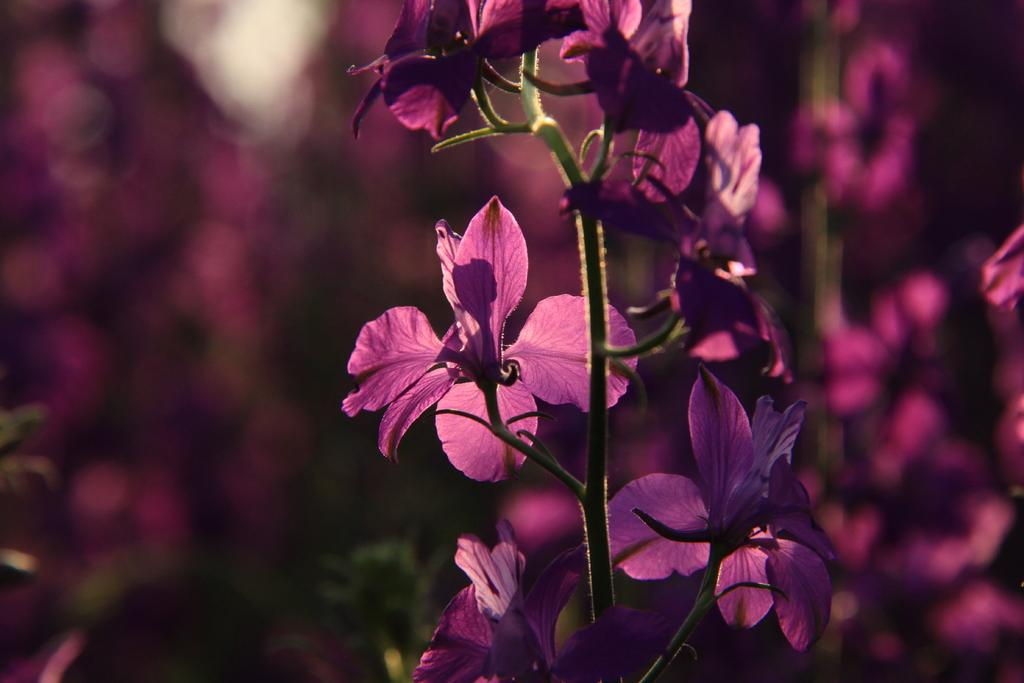What type of plants are visible in the image? There are flowers in the image. What part of the flowers can be seen in the image? There are stems in the image. Can you describe the background of the image? The background of the image is blurry. What type of print can be seen on the sock in the image? There is no sock present in the image, so it is not possible to determine the type of print on it. 